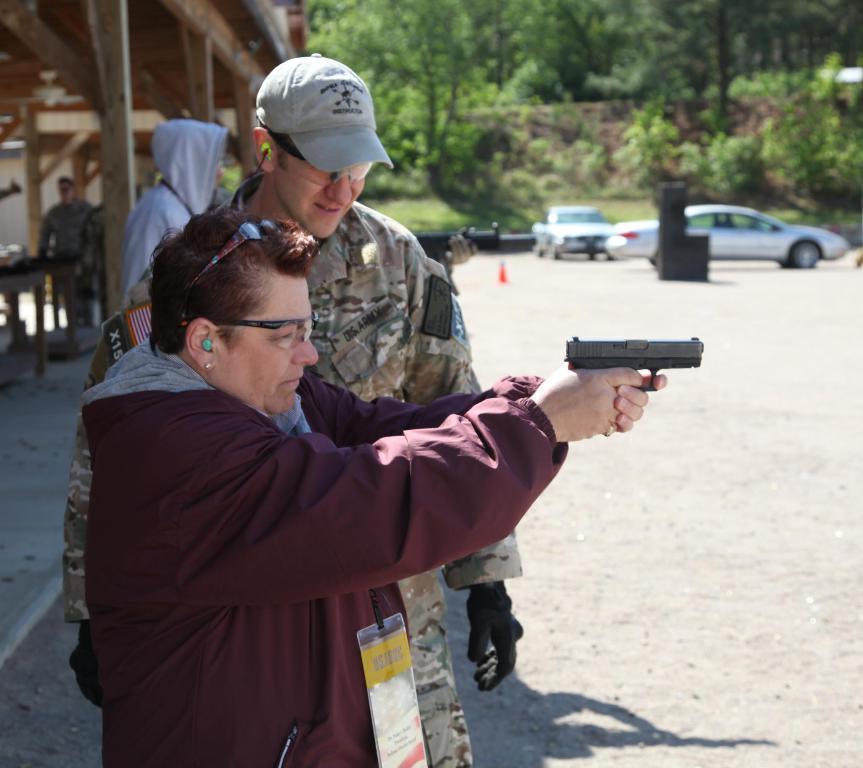Please provide a concise description of this image. This picture is clicked outside. In the foreground there is a person holding a gun and standing on the ground and there is a man wearing a uniform and standing. On the left we can see the group of persons and some other objects. On the right there are some vehicles seems to be parked on the ground. In the background we can see the trees and plants. 